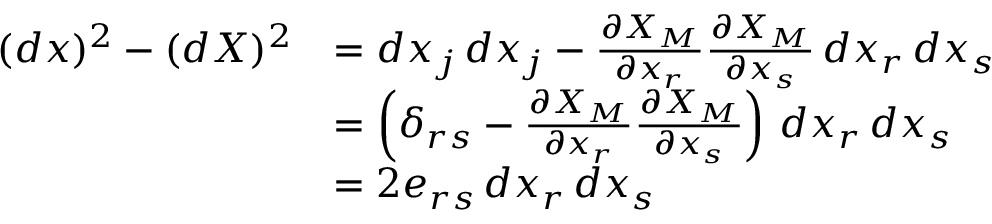<formula> <loc_0><loc_0><loc_500><loc_500>{ \begin{array} { r l } { ( d x ) ^ { 2 } - ( d X ) ^ { 2 } } & { = d x _ { j } \, d x _ { j } - { \frac { \partial X _ { M } } { \partial x _ { r } } } { \frac { \partial X _ { M } } { \partial x _ { s } } } \, d x _ { r } \, d x _ { s } } \\ & { = \left ( \delta _ { r s } - { \frac { \partial X _ { M } } { \partial x _ { r } } } { \frac { \partial X _ { M } } { \partial x _ { s } } } \right ) \, d x _ { r } \, d x _ { s } } \\ & { = 2 e _ { r s } \, d x _ { r } \, d x _ { s } } \end{array} }</formula> 